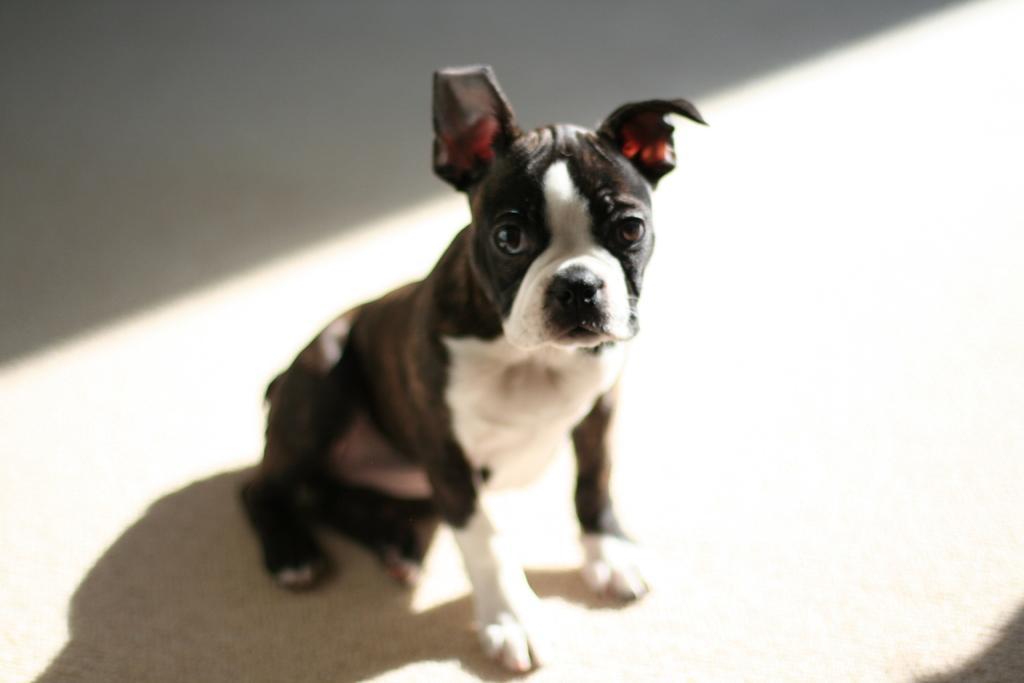In one or two sentences, can you explain what this image depicts? In the picture we can see a dog sitting on the white color floor and the dog is black and some part is white in color. 